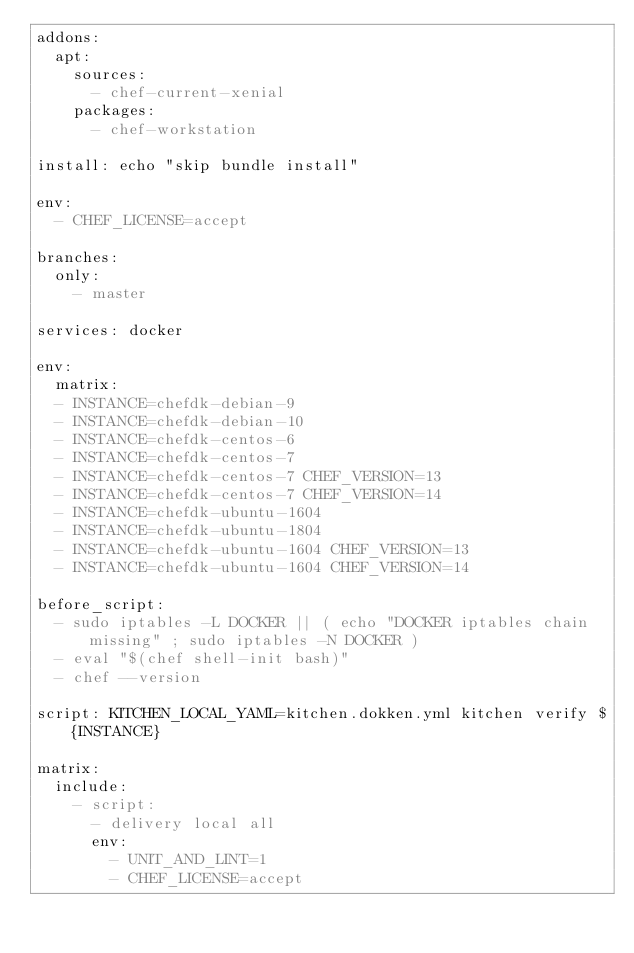<code> <loc_0><loc_0><loc_500><loc_500><_YAML_>addons:
  apt:
    sources:
      - chef-current-xenial
    packages:
      - chef-workstation

install: echo "skip bundle install"

env:
  - CHEF_LICENSE=accept

branches:
  only:
    - master

services: docker

env:
  matrix:
  - INSTANCE=chefdk-debian-9
  - INSTANCE=chefdk-debian-10
  - INSTANCE=chefdk-centos-6
  - INSTANCE=chefdk-centos-7
  - INSTANCE=chefdk-centos-7 CHEF_VERSION=13
  - INSTANCE=chefdk-centos-7 CHEF_VERSION=14
  - INSTANCE=chefdk-ubuntu-1604
  - INSTANCE=chefdk-ubuntu-1804
  - INSTANCE=chefdk-ubuntu-1604 CHEF_VERSION=13
  - INSTANCE=chefdk-ubuntu-1604 CHEF_VERSION=14

before_script:
  - sudo iptables -L DOCKER || ( echo "DOCKER iptables chain missing" ; sudo iptables -N DOCKER )
  - eval "$(chef shell-init bash)"
  - chef --version

script: KITCHEN_LOCAL_YAML=kitchen.dokken.yml kitchen verify ${INSTANCE}

matrix:
  include:
    - script:
      - delivery local all
      env:
        - UNIT_AND_LINT=1
        - CHEF_LICENSE=accept
</code> 